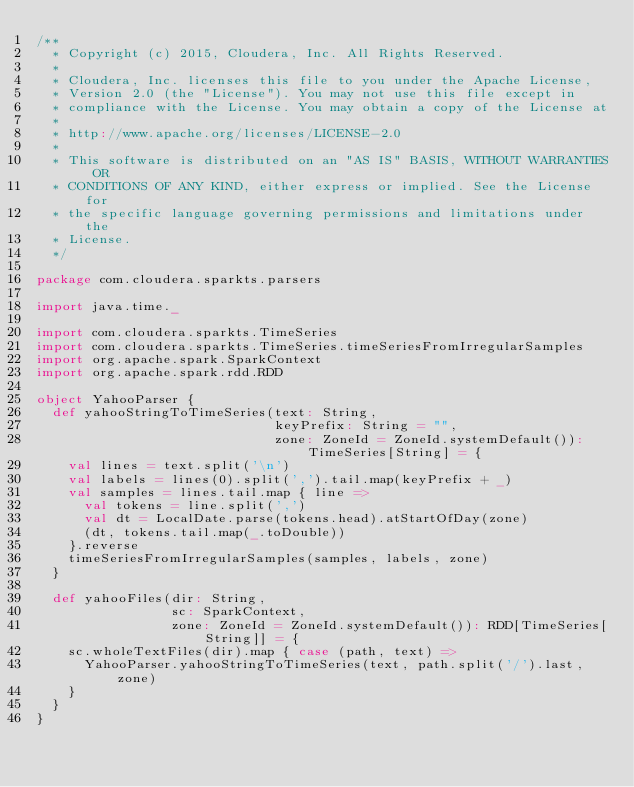<code> <loc_0><loc_0><loc_500><loc_500><_Scala_>/**
  * Copyright (c) 2015, Cloudera, Inc. All Rights Reserved.
  *
  * Cloudera, Inc. licenses this file to you under the Apache License,
  * Version 2.0 (the "License"). You may not use this file except in
  * compliance with the License. You may obtain a copy of the License at
  *
  * http://www.apache.org/licenses/LICENSE-2.0
  *
  * This software is distributed on an "AS IS" BASIS, WITHOUT WARRANTIES OR
  * CONDITIONS OF ANY KIND, either express or implied. See the License for
  * the specific language governing permissions and limitations under the
  * License.
  */

package com.cloudera.sparkts.parsers

import java.time._

import com.cloudera.sparkts.TimeSeries
import com.cloudera.sparkts.TimeSeries.timeSeriesFromIrregularSamples
import org.apache.spark.SparkContext
import org.apache.spark.rdd.RDD

object YahooParser {
  def yahooStringToTimeSeries(text: String,
                              keyPrefix: String = "",
                              zone: ZoneId = ZoneId.systemDefault()): TimeSeries[String] = {
    val lines = text.split('\n')
    val labels = lines(0).split(',').tail.map(keyPrefix + _)
    val samples = lines.tail.map { line =>
      val tokens = line.split(',')
      val dt = LocalDate.parse(tokens.head).atStartOfDay(zone)
      (dt, tokens.tail.map(_.toDouble))
    }.reverse
    timeSeriesFromIrregularSamples(samples, labels, zone)
  }

  def yahooFiles(dir: String,
                 sc: SparkContext,
                 zone: ZoneId = ZoneId.systemDefault()): RDD[TimeSeries[String]] = {
    sc.wholeTextFiles(dir).map { case (path, text) =>
      YahooParser.yahooStringToTimeSeries(text, path.split('/').last, zone)
    }
  }
}
</code> 